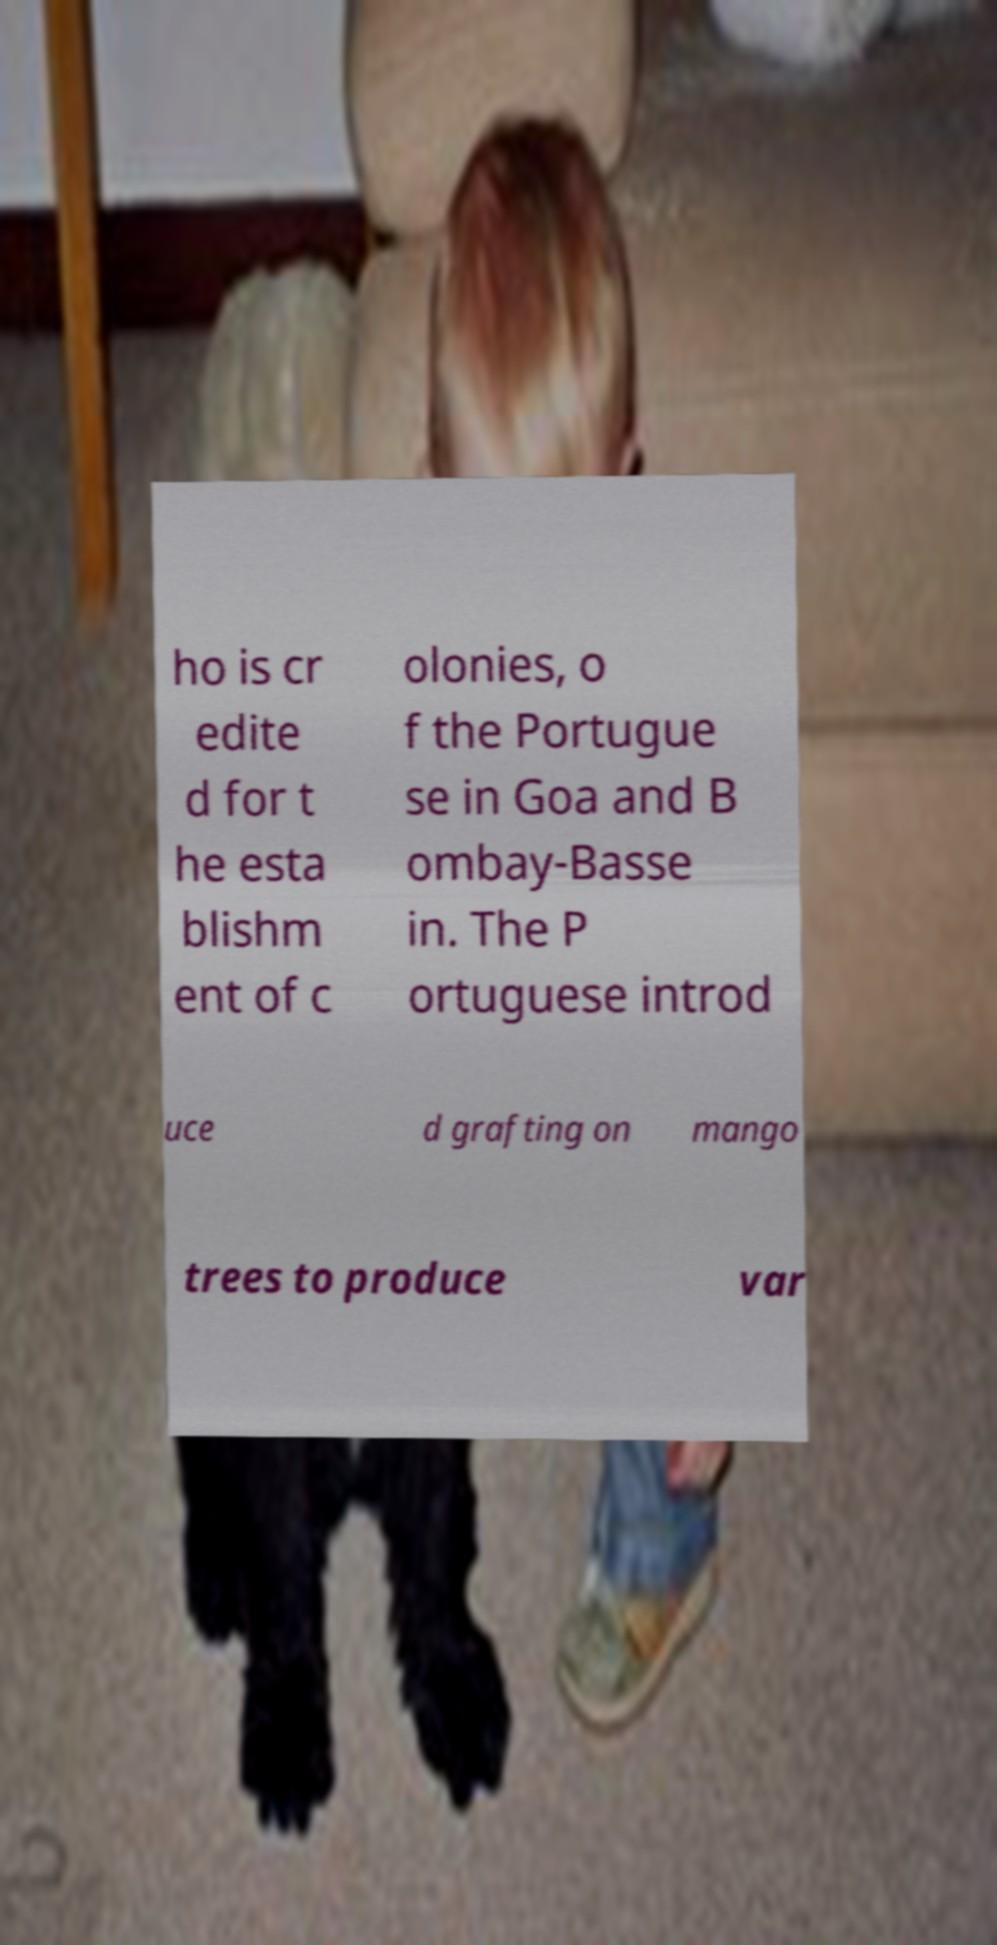I need the written content from this picture converted into text. Can you do that? ho is cr edite d for t he esta blishm ent of c olonies, o f the Portugue se in Goa and B ombay-Basse in. The P ortuguese introd uce d grafting on mango trees to produce var 